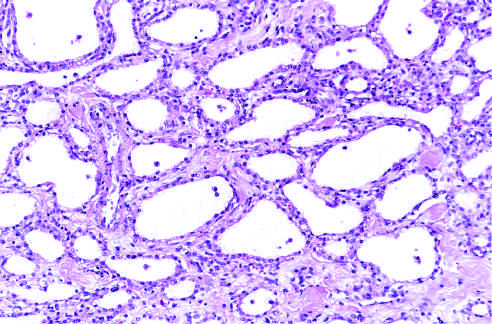s this specimen from a patient with hemolytic uremic syndrome lined by cuboidal epithelium without atypia?
Answer the question using a single word or phrase. No 